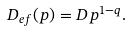<formula> <loc_0><loc_0><loc_500><loc_500>D _ { e f } ( p ) = D p ^ { 1 - q } .</formula> 